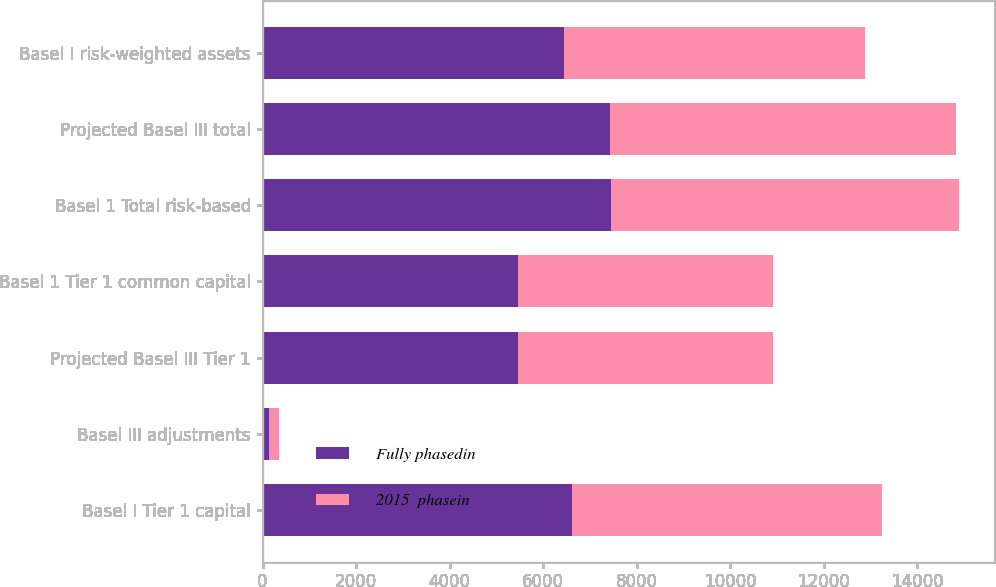<chart> <loc_0><loc_0><loc_500><loc_500><stacked_bar_chart><ecel><fcel>Basel I Tier 1 capital<fcel>Basel III adjustments<fcel>Projected Basel III Tier 1<fcel>Basel 1 Tier 1 common capital<fcel>Basel 1 Total risk-based<fcel>Projected Basel III total<fcel>Basel I risk-weighted assets<nl><fcel>Fully phasedin<fcel>6620<fcel>131<fcel>5469<fcel>5453<fcel>7443<fcel>7439<fcel>6441.5<nl><fcel>2015  phasein<fcel>6620<fcel>226<fcel>5454<fcel>5453<fcel>7443<fcel>7385<fcel>6441.5<nl></chart> 